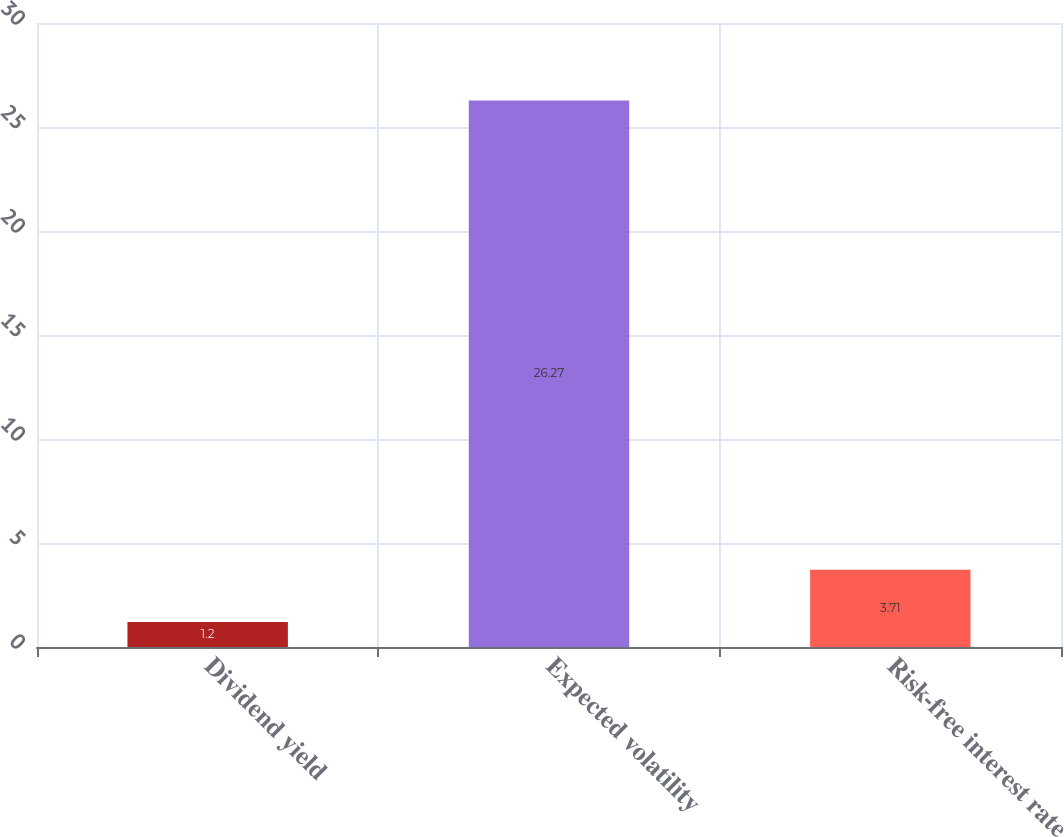<chart> <loc_0><loc_0><loc_500><loc_500><bar_chart><fcel>Dividend yield<fcel>Expected volatility<fcel>Risk-free interest rate<nl><fcel>1.2<fcel>26.27<fcel>3.71<nl></chart> 